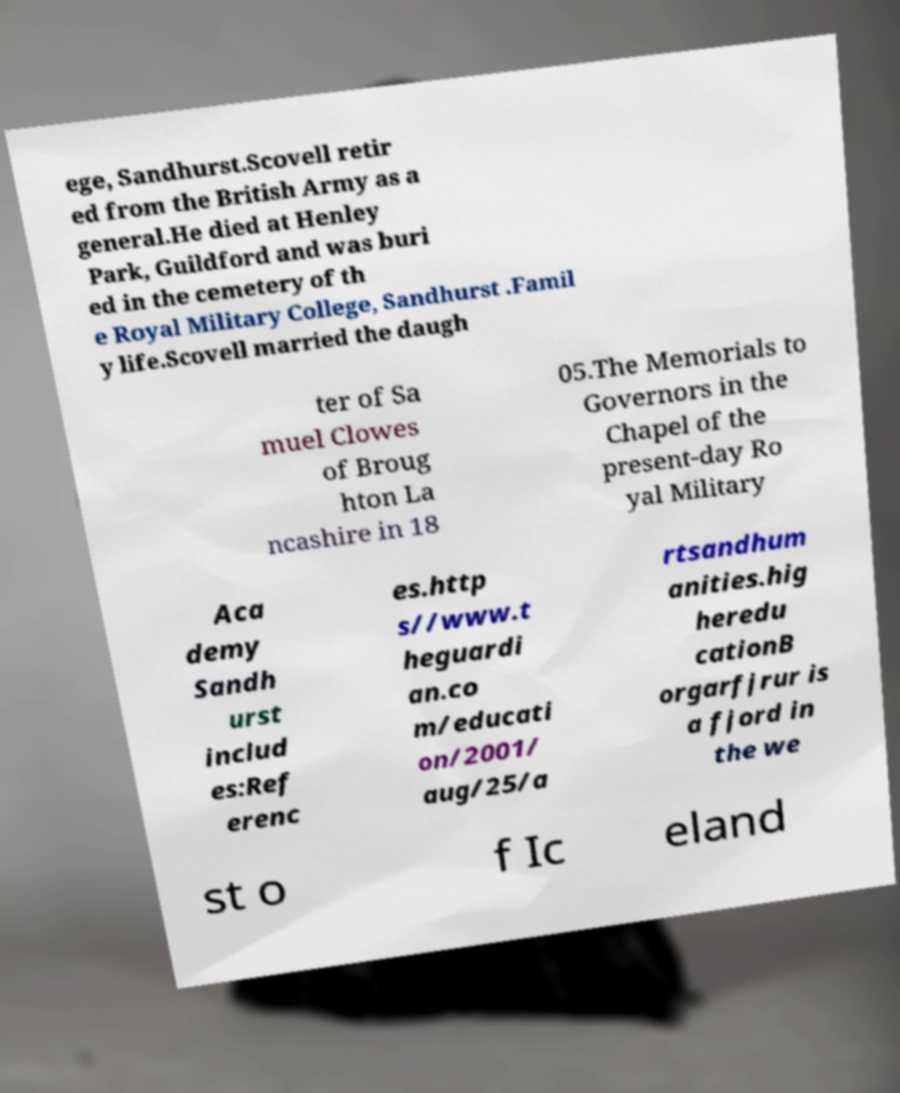Can you accurately transcribe the text from the provided image for me? ege, Sandhurst.Scovell retir ed from the British Army as a general.He died at Henley Park, Guildford and was buri ed in the cemetery of th e Royal Military College, Sandhurst .Famil y life.Scovell married the daugh ter of Sa muel Clowes of Broug hton La ncashire in 18 05.The Memorials to Governors in the Chapel of the present-day Ro yal Military Aca demy Sandh urst includ es:Ref erenc es.http s//www.t heguardi an.co m/educati on/2001/ aug/25/a rtsandhum anities.hig heredu cationB orgarfjrur is a fjord in the we st o f Ic eland 